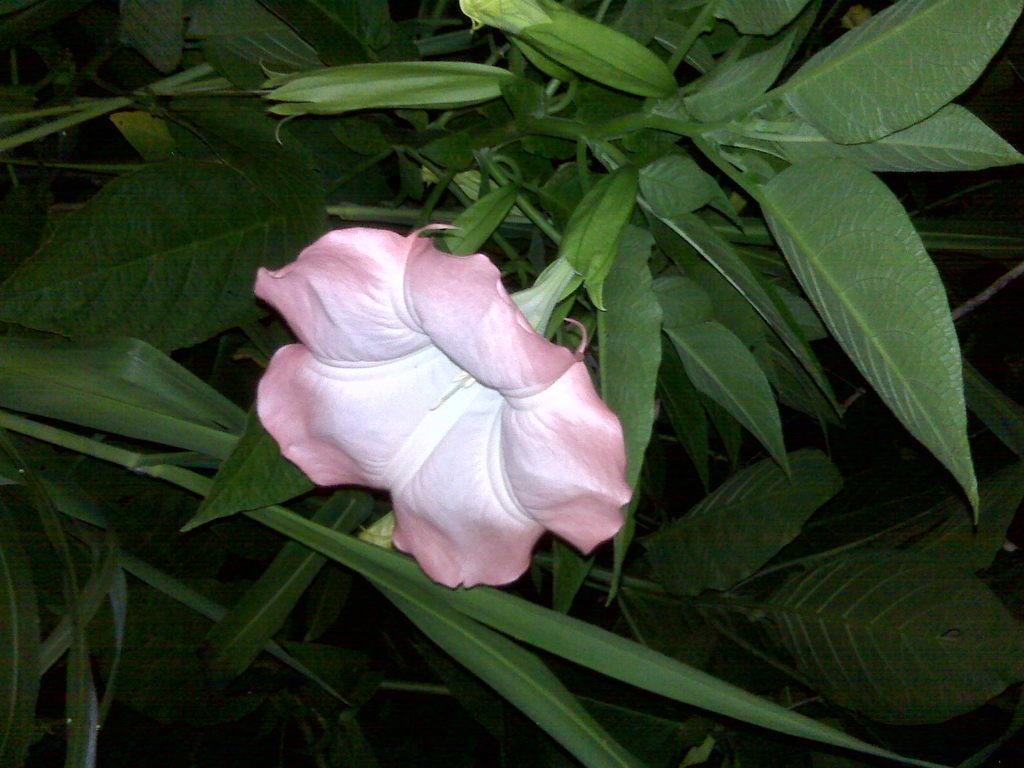What is the main subject in the center of the image? There is a flower in the center of the image. What else can be seen in the image besides the flower? There are plants in the image. What type of dog is sitting next to the lawyer in the downtown area in the image? There is no dog, lawyer, or downtown area present in the image; it only features a flower and plants. 